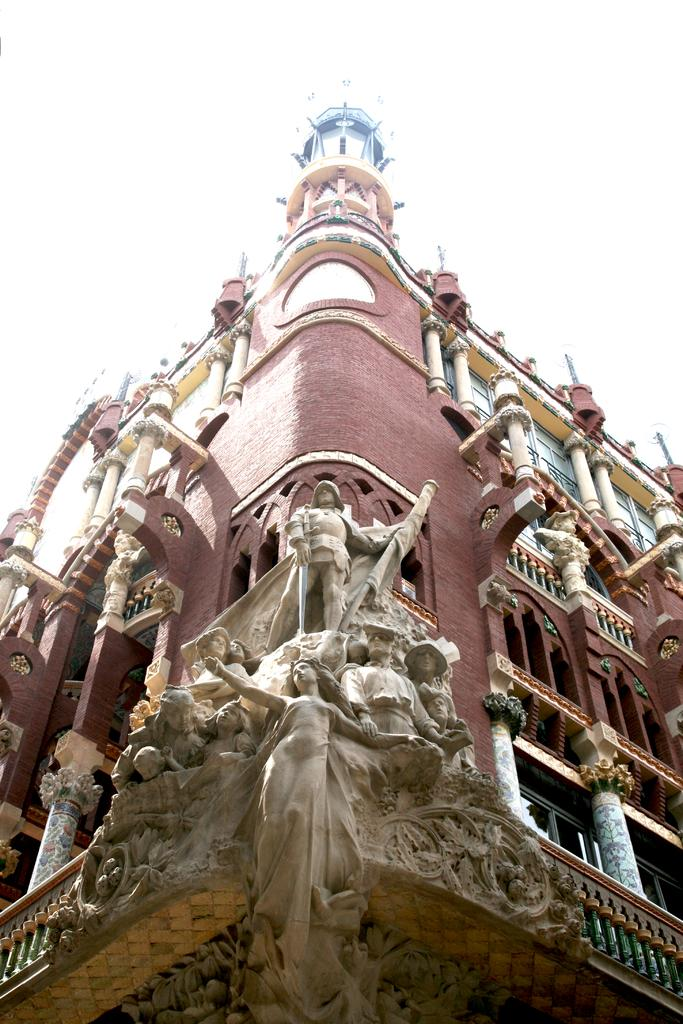What type of structure is visible in the image? There is a building in the image. What features can be seen on the building? The building has windows, pillars, statues, and concrete fencing. What is visible at the top of the image? The sky is visible at the top of the image. How many apples are being held by the fairies on the building in the image? There are no fairies or apples present in the image. What type of sack is being used to carry the statues on the building in the image? There is no sack visible in the image, and the statues are not being carried by any object. 